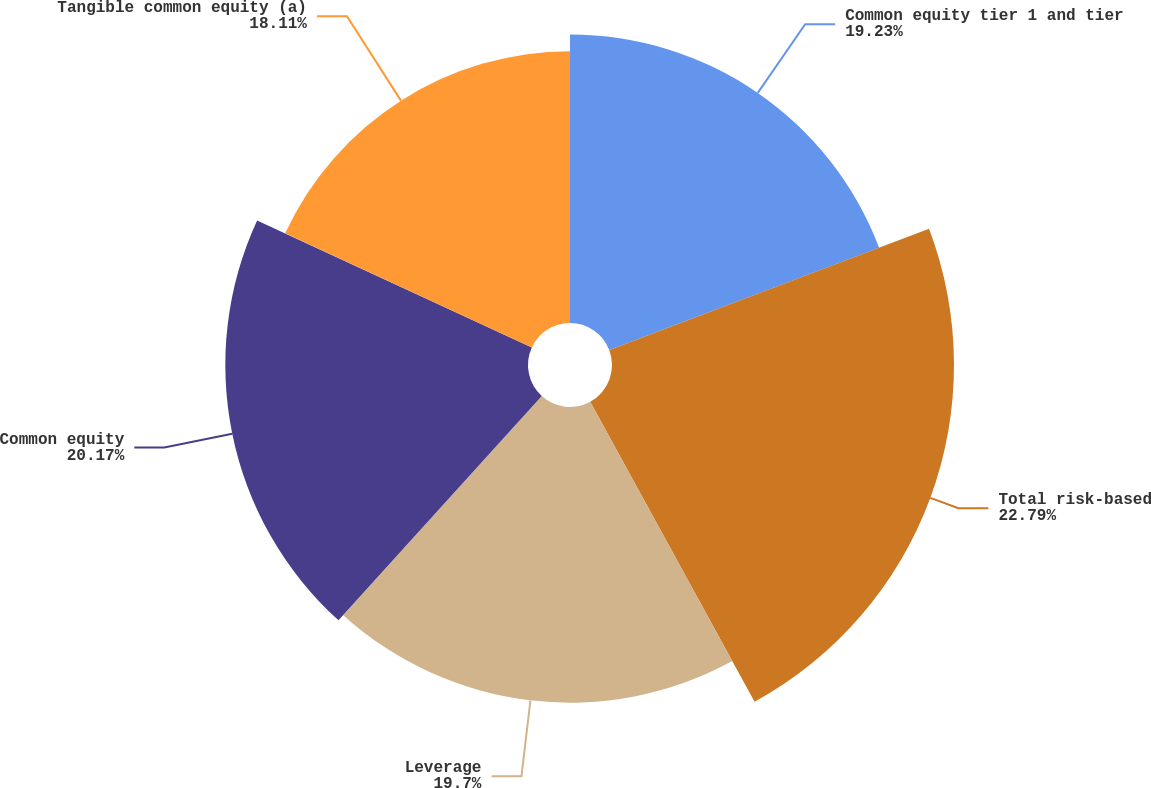Convert chart. <chart><loc_0><loc_0><loc_500><loc_500><pie_chart><fcel>Common equity tier 1 and tier<fcel>Total risk-based<fcel>Leverage<fcel>Common equity<fcel>Tangible common equity (a)<nl><fcel>19.23%<fcel>22.79%<fcel>19.7%<fcel>20.17%<fcel>18.11%<nl></chart> 